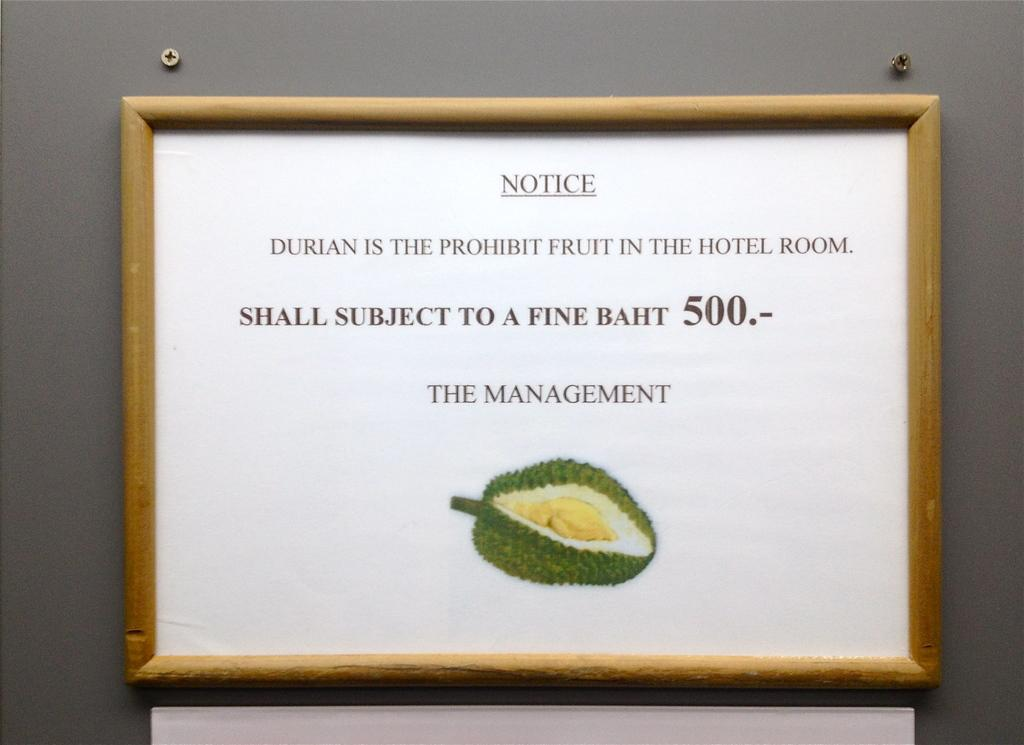<image>
Summarize the visual content of the image. Durian is the prohibit fruit in the hotel room notice in a frame. 